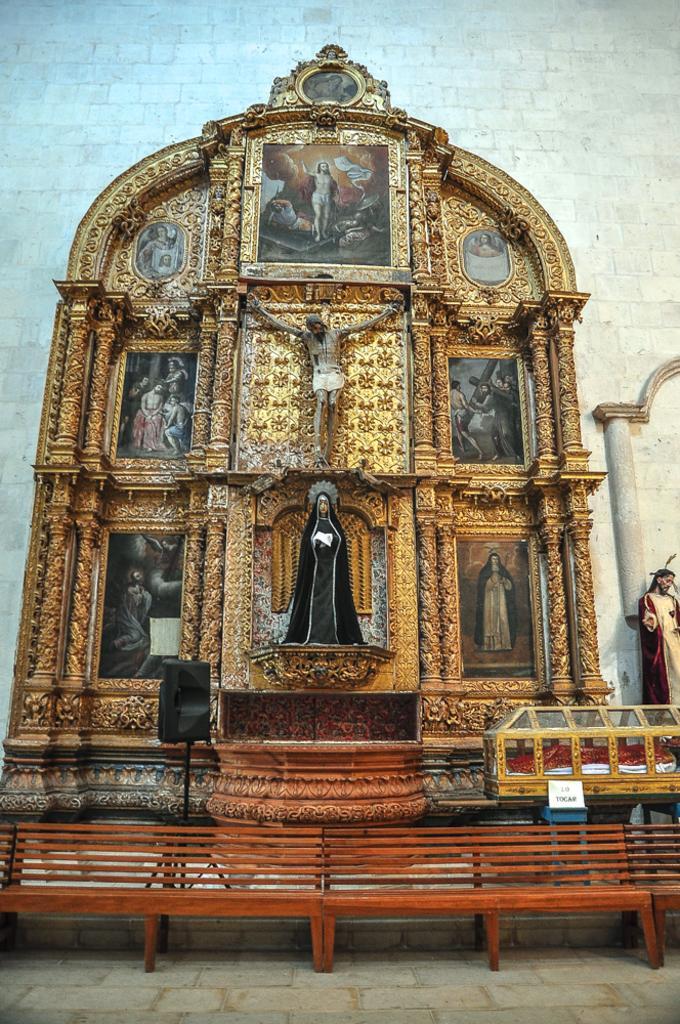In one or two sentences, can you explain what this image depicts? In this picture we can see status and photo frames, at the bottom there are benches, in the background there is a wall, we can see a speaker here. 